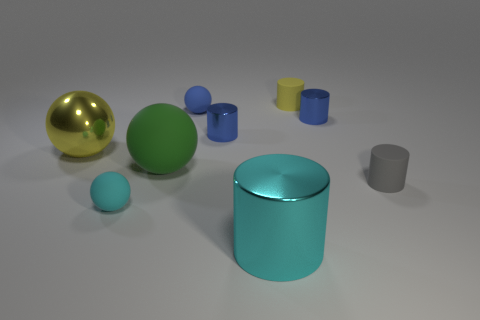What number of cylinders are the same color as the big metallic ball?
Offer a terse response. 1. How many objects are on the right side of the large green object and to the left of the large cyan cylinder?
Provide a short and direct response. 2. The yellow thing that is the same size as the blue matte thing is what shape?
Provide a succinct answer. Cylinder. How big is the green thing?
Ensure brevity in your answer.  Large. There is a small blue sphere on the left side of the rubber cylinder behind the metal object to the left of the blue rubber thing; what is it made of?
Make the answer very short. Rubber. The large thing that is the same material as the cyan cylinder is what color?
Your answer should be compact. Yellow. How many metallic objects are in front of the object to the left of the cyan thing that is on the left side of the large green rubber object?
Provide a short and direct response. 1. There is a tiny thing that is the same color as the metal sphere; what material is it?
Keep it short and to the point. Rubber. What number of things are large metal things in front of the big yellow sphere or cylinders?
Ensure brevity in your answer.  5. Is the color of the ball in front of the green rubber sphere the same as the big cylinder?
Provide a short and direct response. Yes. 